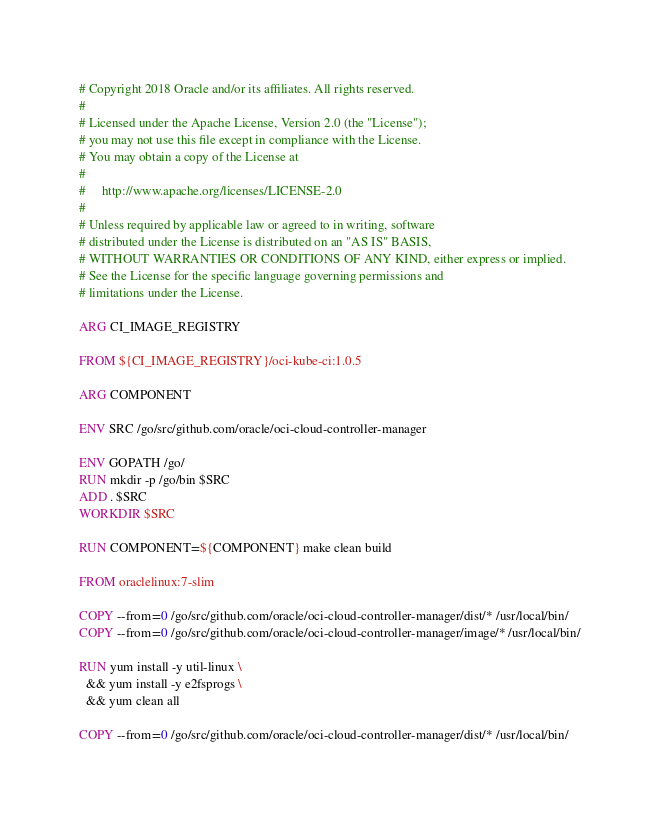<code> <loc_0><loc_0><loc_500><loc_500><_Dockerfile_># Copyright 2018 Oracle and/or its affiliates. All rights reserved.
#
# Licensed under the Apache License, Version 2.0 (the "License");
# you may not use this file except in compliance with the License.
# You may obtain a copy of the License at
#
#     http://www.apache.org/licenses/LICENSE-2.0
#
# Unless required by applicable law or agreed to in writing, software
# distributed under the License is distributed on an "AS IS" BASIS,
# WITHOUT WARRANTIES OR CONDITIONS OF ANY KIND, either express or implied.
# See the License for the specific language governing permissions and
# limitations under the License.

ARG CI_IMAGE_REGISTRY

FROM ${CI_IMAGE_REGISTRY}/oci-kube-ci:1.0.5

ARG COMPONENT

ENV SRC /go/src/github.com/oracle/oci-cloud-controller-manager

ENV GOPATH /go/
RUN mkdir -p /go/bin $SRC
ADD . $SRC
WORKDIR $SRC

RUN COMPONENT=${COMPONENT} make clean build

FROM oraclelinux:7-slim

COPY --from=0 /go/src/github.com/oracle/oci-cloud-controller-manager/dist/* /usr/local/bin/
COPY --from=0 /go/src/github.com/oracle/oci-cloud-controller-manager/image/* /usr/local/bin/

RUN yum install -y util-linux \
  && yum install -y e2fsprogs \
  && yum clean all

COPY --from=0 /go/src/github.com/oracle/oci-cloud-controller-manager/dist/* /usr/local/bin/
</code> 